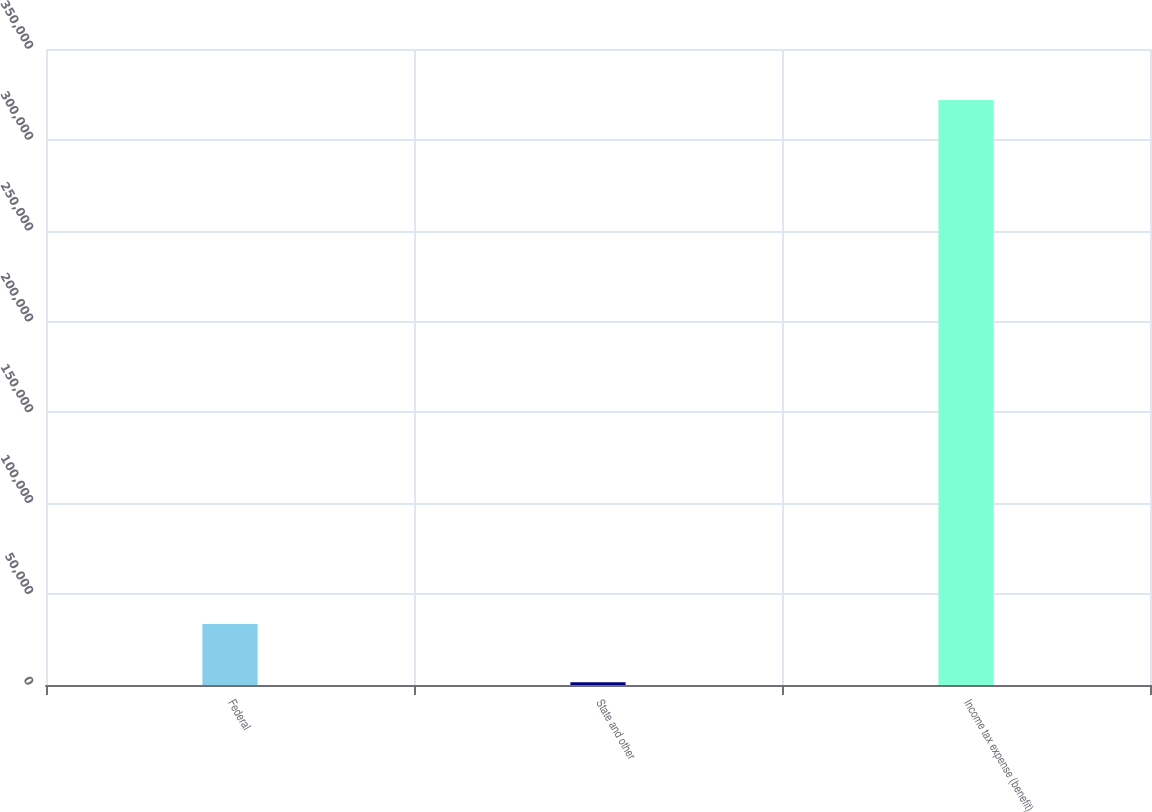<chart> <loc_0><loc_0><loc_500><loc_500><bar_chart><fcel>Federal<fcel>State and other<fcel>Income tax expense (benefit)<nl><fcel>33519.9<fcel>1474<fcel>321933<nl></chart> 